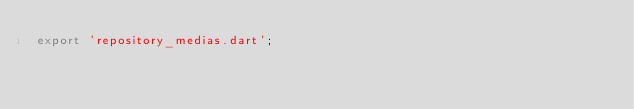Convert code to text. <code><loc_0><loc_0><loc_500><loc_500><_Dart_>export 'repository_medias.dart';
</code> 